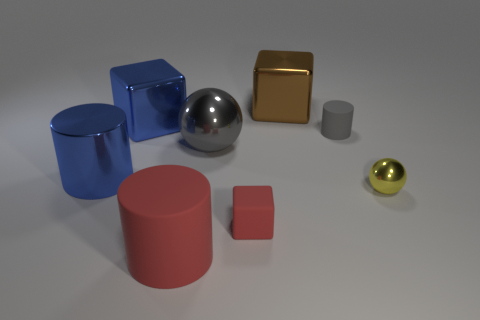There is a big metal ball; is its color the same as the small thing that is behind the tiny yellow thing?
Your answer should be compact. Yes. There is a metallic ball on the left side of the large brown thing; what is its color?
Make the answer very short. Gray. There is a blue object to the left of the blue metal block to the left of the big metallic ball; what is its shape?
Give a very brief answer. Cylinder. Is the material of the yellow sphere the same as the cylinder in front of the small yellow sphere?
Your answer should be very brief. No. What shape is the thing that is the same color as the tiny matte block?
Make the answer very short. Cylinder. What number of other gray matte things are the same size as the gray matte object?
Your response must be concise. 0. Are there fewer small red rubber objects that are behind the metallic cylinder than big brown metallic cylinders?
Offer a terse response. No. How many big blue objects are on the left side of the big blue metallic cube?
Give a very brief answer. 1. How big is the rubber cylinder behind the blue shiny thing in front of the matte cylinder that is behind the tiny sphere?
Provide a succinct answer. Small. There is a tiny gray thing; is it the same shape as the red rubber thing to the left of the large gray metal ball?
Ensure brevity in your answer.  Yes. 